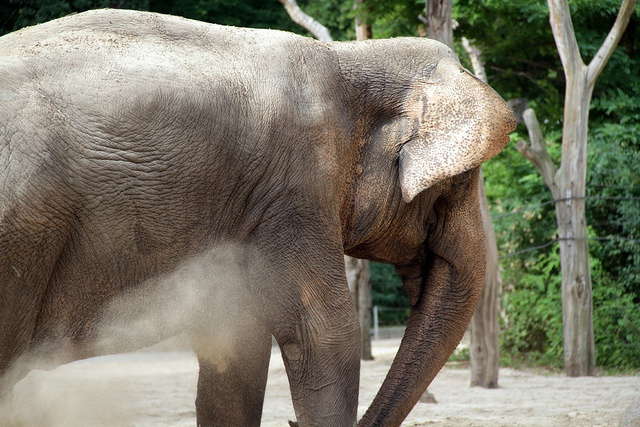Describe the objects in this image and their specific colors. I can see a elephant in black, gray, darkgray, and lightgray tones in this image. 